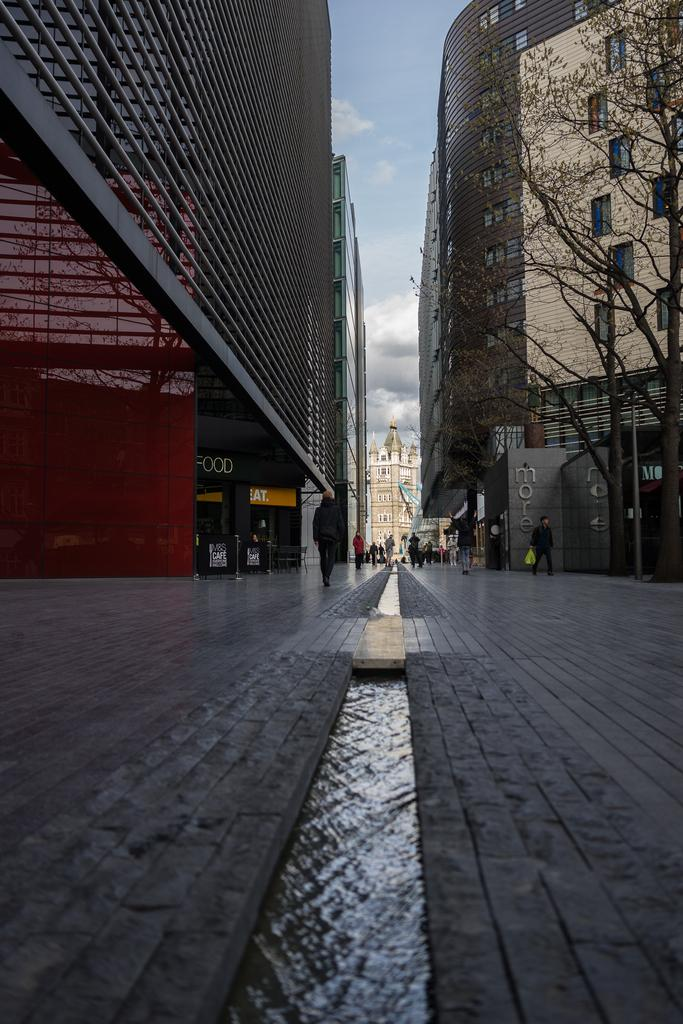<image>
Create a compact narrative representing the image presented. A very long city walkway is between two rather large buildings with people around and signs saying FOOD, EAT, and more. 